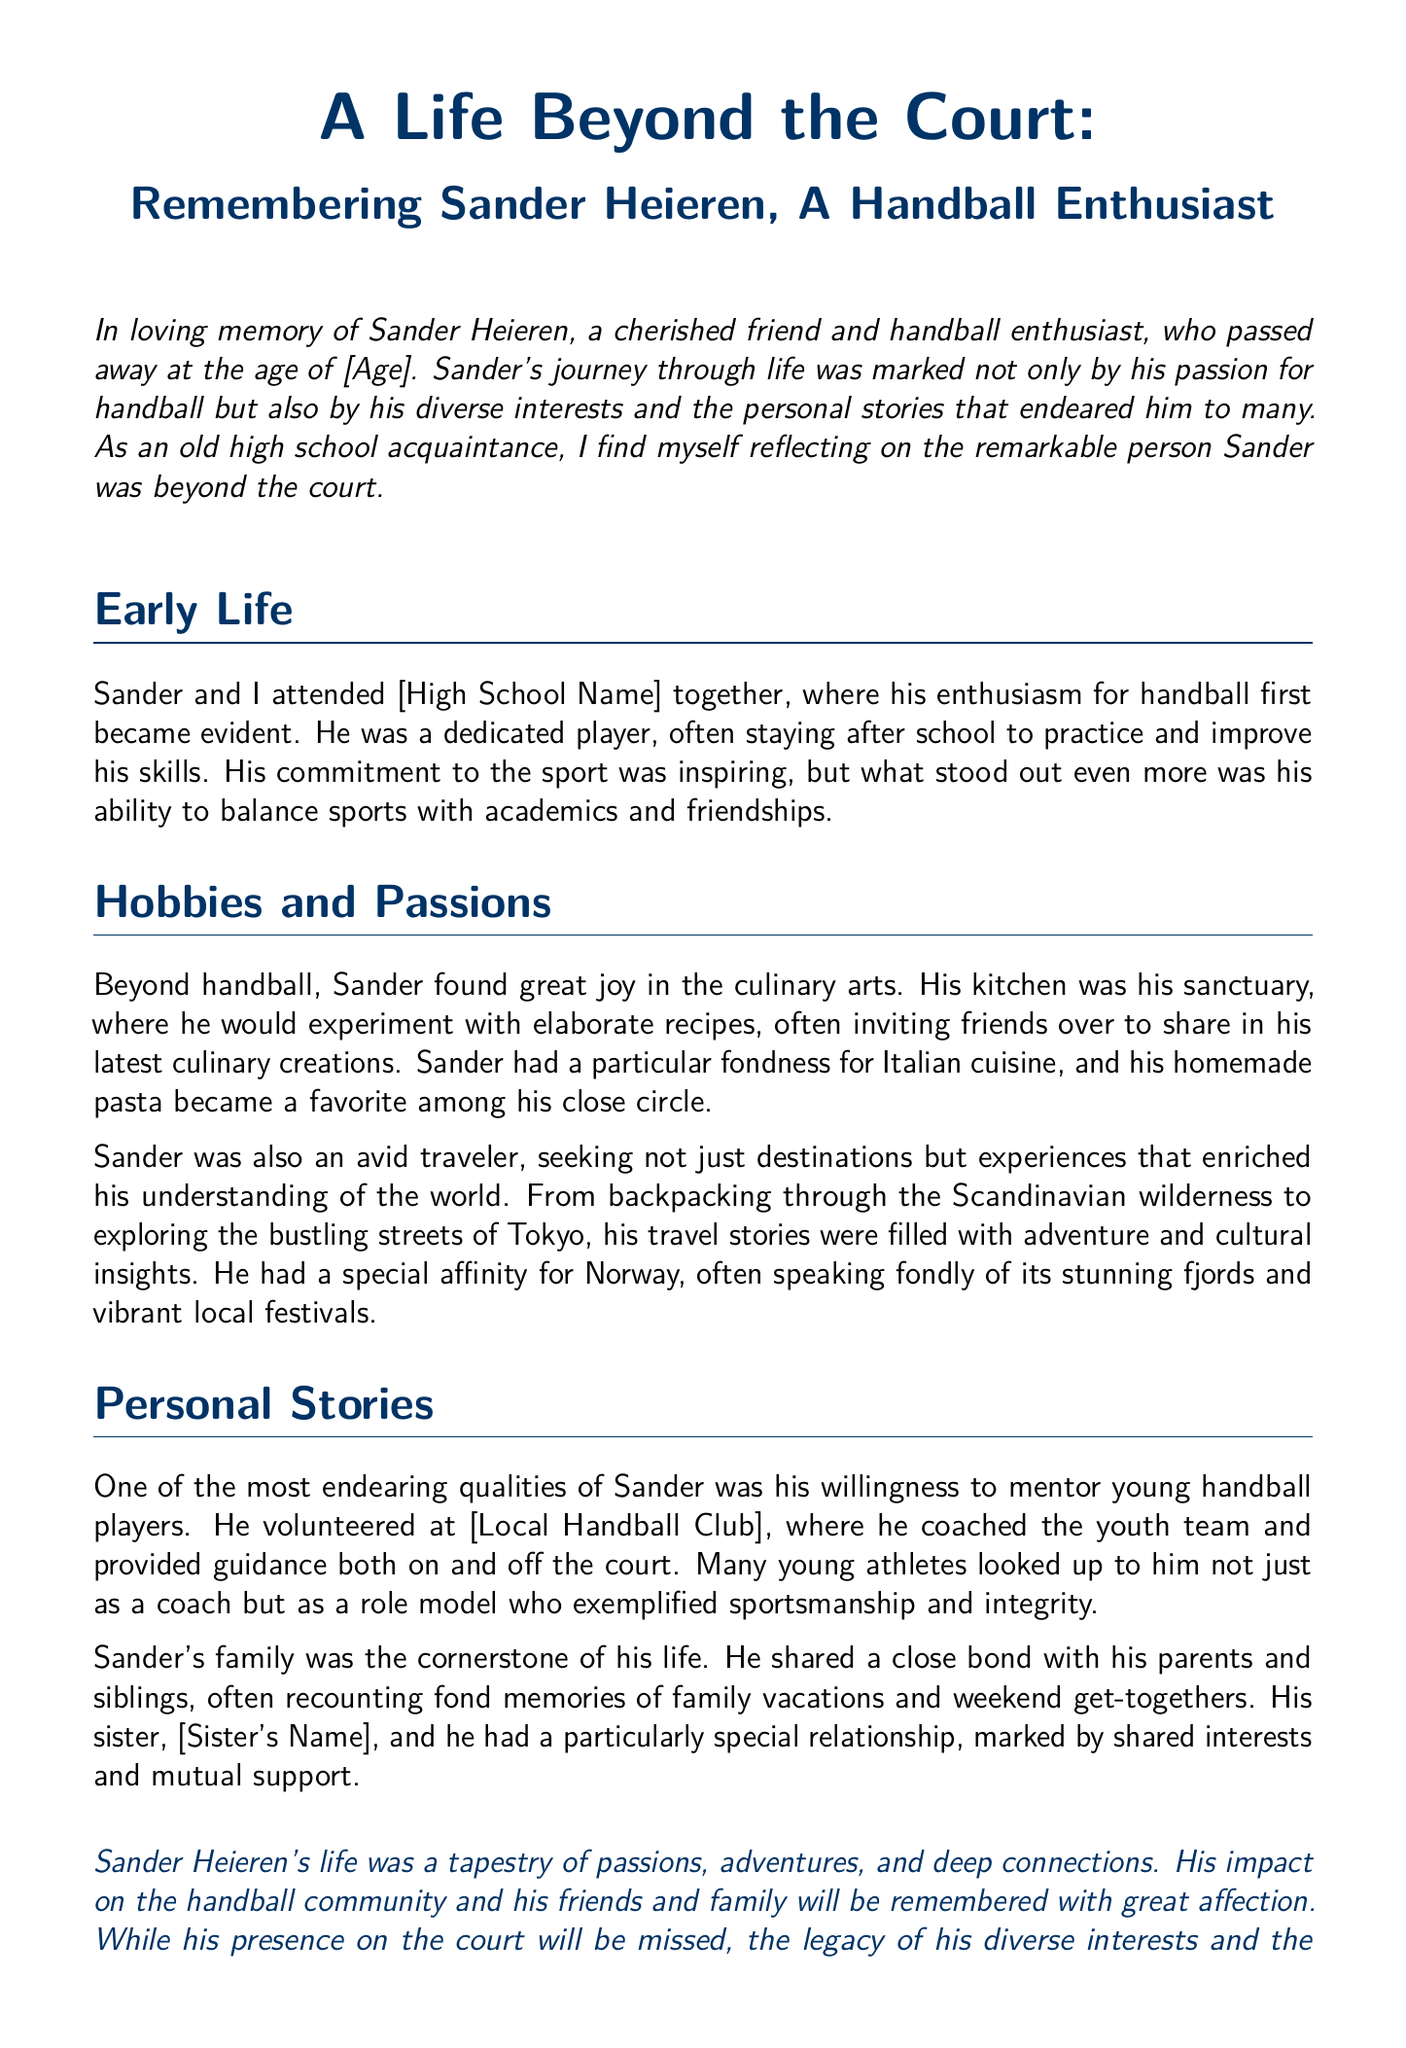What was Sander's age at the time of passing? The document states that Sander passed away at the age of [Age], which needs to be filled in with the actual number.
Answer: [Age] What high school did Sander attend? The document mentions that Sander and the author attended [High School Name] together, which needs to be filled in with the actual name.
Answer: [High School Name] What cuisine did Sander particularly enjoy? The document notes Sander had a fondness for Italian cuisine, which reflects his culinary interests.
Answer: Italian cuisine Where did Sander volunteer as a coach? The document states that Sander volunteered at [Local Handball Club], which should be specified in the text.
Answer: [Local Handball Club] What type of trips did Sander prefer? The document describes Sander as an avid traveler, specifically mentioning backpacking through the Scandinavian wilderness and other experiences.
Answer: Backpacking Who had a special relationship with Sander? The document highlights Sander's close bond with his sister, [Sister's Name], emphasizing their mutual support and shared interests.
Answer: [Sister's Name] What qualities did Sander exemplify as a coach? The document mentions that Sander was not just a coach but a role model who exemplified sportsmanship and integrity.
Answer: Sportsmanship and integrity What personal stories did Sander often recount? The document notes that Sander often recounted fond memories of family vacations and weekend get-togethers, indicating his family values.
Answer: Family vacations and get-togethers 